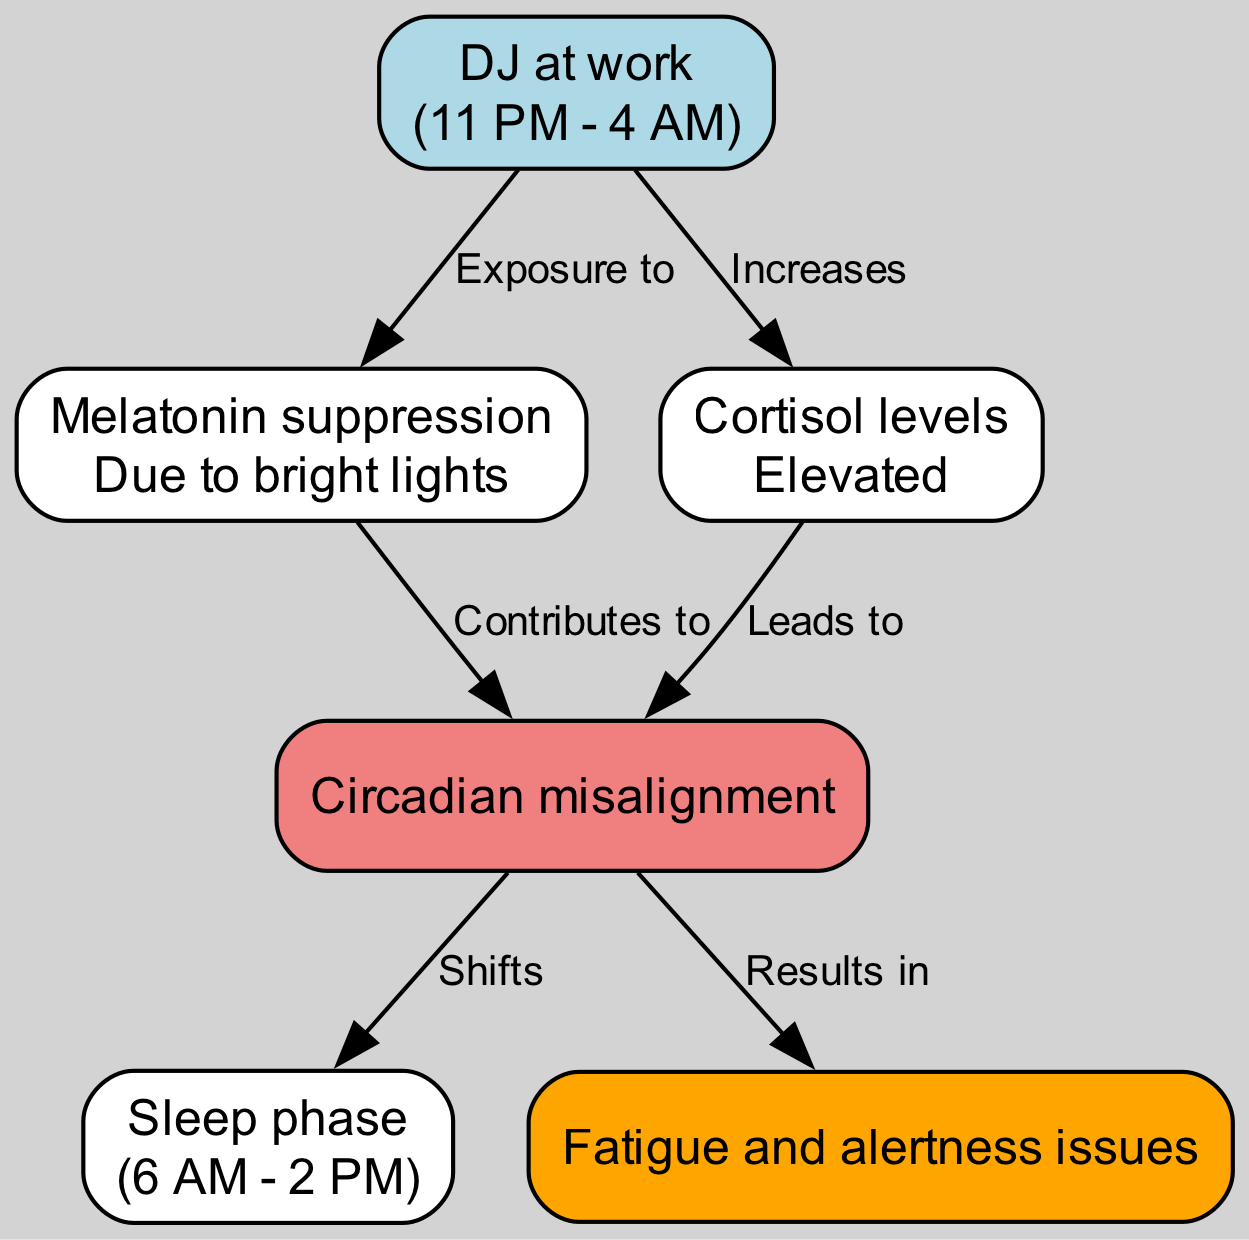What is the time range for the DJ at work? The node labeled "DJ at work" specifies the time as "11 PM - 4 AM." Therefore, the answer is derived directly from the information present in the diagram.
Answer: 11 PM - 4 AM What node contributes to melatonin suppression? The diagram shows an edge labeled "Exposure to" leading from the "DJ at work" node to the "Melatonin suppression" node, indicating that being a DJ contributes to melatonin suppression.
Answer: DJ at work How many nodes are in the diagram? By counting the items under the "nodes" key in the data, we find there are six different nodes listed. Thus, the total count yields the answer.
Answer: 6 What does elevated cortisol levels lead to? The diagram illustrates a flow from the "Cortisol levels" node (elevated state) to the "Circadian misalignment" node, indicating the influence of elevated cortisol levels on circadian rhythm.
Answer: Circadian misalignment What results from circadian misalignment? Following the edges from the "Circadian misalignment" node, there are two outgoing edges: one leads to "Sleep phase" (shifts) and another to "Fatigue and alertness issues," meaning that both outcomes are consequences of circadian misalignment.
Answer: Fatigue and alertness issues Which node indicates sleep phase changes? The node labeled "Sleep phase" shows a time range of "6 AM - 2 PM," indicating that this is the time when sleep phase changes occur due to circadian rhythm disruption.
Answer: Sleep phase What contributes to circadian misalignment? The diagram indicates two factors contributing to "Circadian misalignment": "Melatonin suppression" from exposure to lights and "Elevated cortisol levels" from working late. Both nodes create a direct correlation towards misalignment.
Answer: Melatonin suppression What happens as a result of fatigue and alertness issues? According to the diagram, there is a direct flow from the "Fatigue and alertness issues" node to the potential consequences for the individual, illustrating the impact on their daily life.
Answer: Not specified in the diagram 